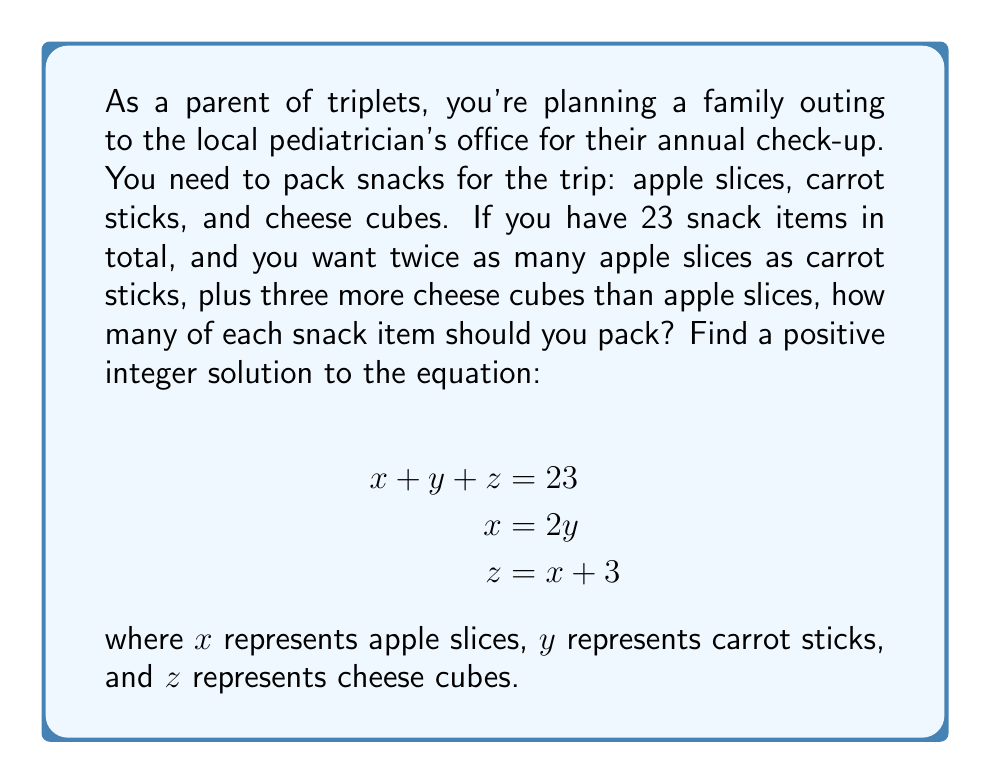Could you help me with this problem? Let's solve this linear Diophantine equation step-by-step:

1) We have three equations:
   $$x + y + z = 23$$ (Equation 1)
   $$x = 2y$$ (Equation 2)
   $$z = x + 3$$ (Equation 3)

2) Substitute Equation 2 into Equation 1:
   $$2y + y + z = 23$$
   $$3y + z = 23$$ (Equation 4)

3) Substitute Equation 2 and Equation 3 into Equation 4:
   $$3y + (2y + 3) = 23$$
   $$5y + 3 = 23$$
   $$5y = 20$$
   $$y = 4$$

4) Now that we know $y = 4$, we can find $x$ using Equation 2:
   $$x = 2y = 2(4) = 8$$

5) Finally, we can find $z$ using Equation 3:
   $$z = x + 3 = 8 + 3 = 11$$

6) Let's verify that our solution satisfies Equation 1:
   $$x + y + z = 8 + 4 + 11 = 23$$

Therefore, the positive integer solution is $x = 8$, $y = 4$, and $z = 11$.
Answer: 8 apple slices, 4 carrot sticks, 11 cheese cubes 